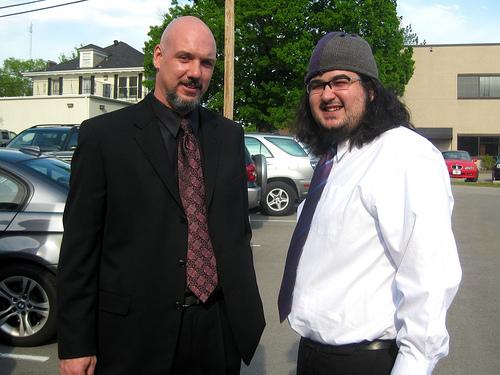Is one of them a woman?
Short answer required. No. Is it daytime?
Concise answer only. Yes. What type of building is this?
Concise answer only. House. Is it sunny?
Quick response, please. Yes. 